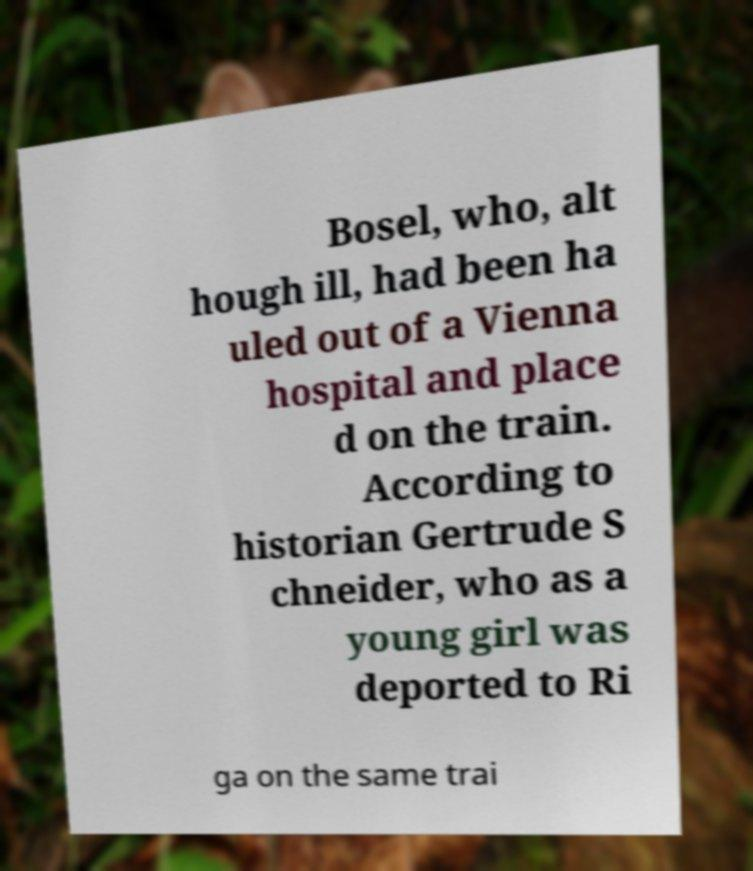There's text embedded in this image that I need extracted. Can you transcribe it verbatim? Bosel, who, alt hough ill, had been ha uled out of a Vienna hospital and place d on the train. According to historian Gertrude S chneider, who as a young girl was deported to Ri ga on the same trai 